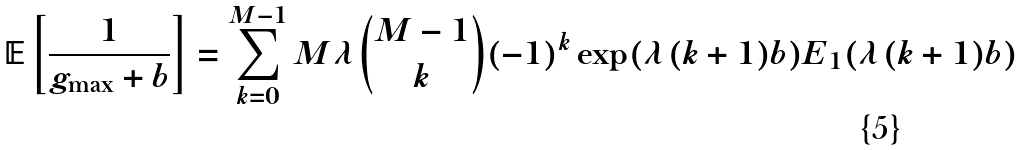Convert formula to latex. <formula><loc_0><loc_0><loc_500><loc_500>\mathbb { E } \left [ \frac { 1 } { g _ { \max } + b } \right ] = \sum _ { k = 0 } ^ { M - 1 } M \lambda \binom { M - 1 } { k } ( - 1 ) ^ { k } \exp ( \lambda ( k + 1 ) b ) E _ { 1 } ( \lambda ( k + 1 ) b )</formula> 